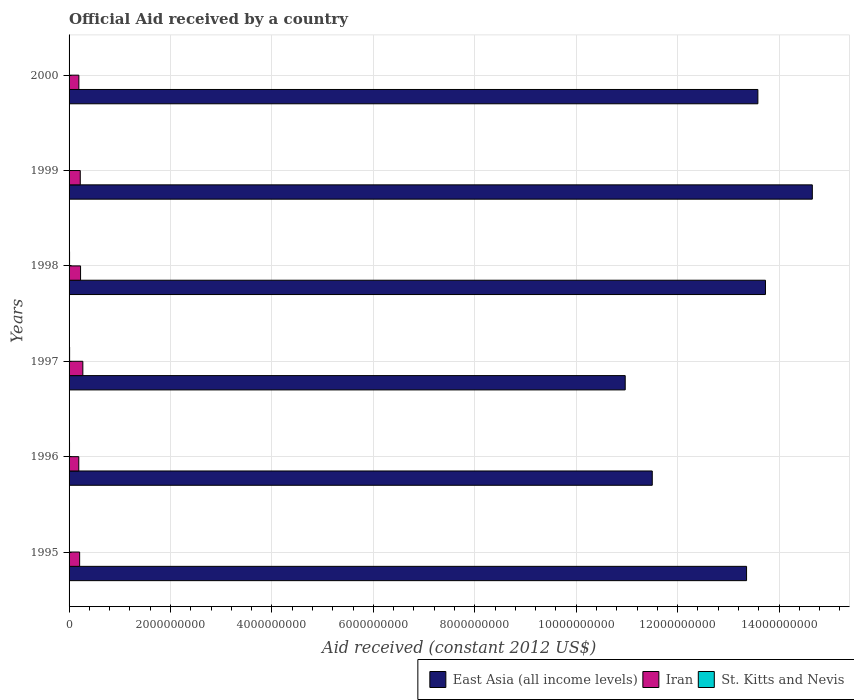Are the number of bars per tick equal to the number of legend labels?
Offer a very short reply. Yes. How many bars are there on the 2nd tick from the bottom?
Ensure brevity in your answer.  3. What is the net official aid received in Iran in 1999?
Offer a terse response. 2.21e+08. Across all years, what is the maximum net official aid received in East Asia (all income levels)?
Provide a succinct answer. 1.47e+1. Across all years, what is the minimum net official aid received in St. Kitts and Nevis?
Keep it short and to the point. 5.01e+06. In which year was the net official aid received in East Asia (all income levels) minimum?
Keep it short and to the point. 1997. What is the total net official aid received in Iran in the graph?
Your answer should be very brief. 1.31e+09. What is the difference between the net official aid received in East Asia (all income levels) in 1996 and that in 1998?
Offer a very short reply. -2.23e+09. What is the difference between the net official aid received in East Asia (all income levels) in 1996 and the net official aid received in Iran in 1995?
Your answer should be very brief. 1.13e+1. What is the average net official aid received in Iran per year?
Provide a short and direct response. 2.19e+08. In the year 1998, what is the difference between the net official aid received in East Asia (all income levels) and net official aid received in St. Kitts and Nevis?
Offer a very short reply. 1.37e+1. In how many years, is the net official aid received in East Asia (all income levels) greater than 4000000000 US$?
Offer a terse response. 6. What is the ratio of the net official aid received in East Asia (all income levels) in 1996 to that in 1999?
Ensure brevity in your answer.  0.78. What is the difference between the highest and the second highest net official aid received in St. Kitts and Nevis?
Make the answer very short. 7.40e+05. What is the difference between the highest and the lowest net official aid received in Iran?
Keep it short and to the point. 8.02e+07. In how many years, is the net official aid received in Iran greater than the average net official aid received in Iran taken over all years?
Your response must be concise. 3. Is the sum of the net official aid received in St. Kitts and Nevis in 1995 and 1997 greater than the maximum net official aid received in East Asia (all income levels) across all years?
Keep it short and to the point. No. What does the 2nd bar from the top in 2000 represents?
Offer a terse response. Iran. What does the 3rd bar from the bottom in 1998 represents?
Your answer should be compact. St. Kitts and Nevis. Is it the case that in every year, the sum of the net official aid received in St. Kitts and Nevis and net official aid received in Iran is greater than the net official aid received in East Asia (all income levels)?
Your answer should be very brief. No. How many bars are there?
Offer a terse response. 18. Are all the bars in the graph horizontal?
Make the answer very short. Yes. How many years are there in the graph?
Your answer should be very brief. 6. Are the values on the major ticks of X-axis written in scientific E-notation?
Give a very brief answer. No. Does the graph contain grids?
Provide a succinct answer. Yes. Where does the legend appear in the graph?
Make the answer very short. Bottom right. What is the title of the graph?
Your answer should be very brief. Official Aid received by a country. Does "Myanmar" appear as one of the legend labels in the graph?
Keep it short and to the point. No. What is the label or title of the X-axis?
Offer a terse response. Aid received (constant 2012 US$). What is the label or title of the Y-axis?
Provide a short and direct response. Years. What is the Aid received (constant 2012 US$) in East Asia (all income levels) in 1995?
Your answer should be very brief. 1.34e+1. What is the Aid received (constant 2012 US$) of Iran in 1995?
Your answer should be very brief. 2.08e+08. What is the Aid received (constant 2012 US$) in St. Kitts and Nevis in 1995?
Offer a very short reply. 5.01e+06. What is the Aid received (constant 2012 US$) of East Asia (all income levels) in 1996?
Ensure brevity in your answer.  1.15e+1. What is the Aid received (constant 2012 US$) in Iran in 1996?
Make the answer very short. 1.91e+08. What is the Aid received (constant 2012 US$) in St. Kitts and Nevis in 1996?
Your answer should be very brief. 9.19e+06. What is the Aid received (constant 2012 US$) of East Asia (all income levels) in 1997?
Your answer should be very brief. 1.10e+1. What is the Aid received (constant 2012 US$) in Iran in 1997?
Your answer should be compact. 2.72e+08. What is the Aid received (constant 2012 US$) of St. Kitts and Nevis in 1997?
Provide a succinct answer. 1.05e+07. What is the Aid received (constant 2012 US$) of East Asia (all income levels) in 1998?
Make the answer very short. 1.37e+1. What is the Aid received (constant 2012 US$) of Iran in 1998?
Ensure brevity in your answer.  2.27e+08. What is the Aid received (constant 2012 US$) of St. Kitts and Nevis in 1998?
Make the answer very short. 9.75e+06. What is the Aid received (constant 2012 US$) in East Asia (all income levels) in 1999?
Keep it short and to the point. 1.47e+1. What is the Aid received (constant 2012 US$) of Iran in 1999?
Your response must be concise. 2.21e+08. What is the Aid received (constant 2012 US$) in St. Kitts and Nevis in 1999?
Give a very brief answer. 6.83e+06. What is the Aid received (constant 2012 US$) of East Asia (all income levels) in 2000?
Provide a succinct answer. 1.36e+1. What is the Aid received (constant 2012 US$) of Iran in 2000?
Your answer should be compact. 1.93e+08. What is the Aid received (constant 2012 US$) of St. Kitts and Nevis in 2000?
Keep it short and to the point. 6.15e+06. Across all years, what is the maximum Aid received (constant 2012 US$) of East Asia (all income levels)?
Provide a short and direct response. 1.47e+1. Across all years, what is the maximum Aid received (constant 2012 US$) in Iran?
Your response must be concise. 2.72e+08. Across all years, what is the maximum Aid received (constant 2012 US$) of St. Kitts and Nevis?
Your answer should be compact. 1.05e+07. Across all years, what is the minimum Aid received (constant 2012 US$) in East Asia (all income levels)?
Your response must be concise. 1.10e+1. Across all years, what is the minimum Aid received (constant 2012 US$) in Iran?
Keep it short and to the point. 1.91e+08. Across all years, what is the minimum Aid received (constant 2012 US$) in St. Kitts and Nevis?
Give a very brief answer. 5.01e+06. What is the total Aid received (constant 2012 US$) in East Asia (all income levels) in the graph?
Your response must be concise. 7.78e+1. What is the total Aid received (constant 2012 US$) of Iran in the graph?
Ensure brevity in your answer.  1.31e+09. What is the total Aid received (constant 2012 US$) of St. Kitts and Nevis in the graph?
Provide a succinct answer. 4.74e+07. What is the difference between the Aid received (constant 2012 US$) in East Asia (all income levels) in 1995 and that in 1996?
Provide a succinct answer. 1.86e+09. What is the difference between the Aid received (constant 2012 US$) in Iran in 1995 and that in 1996?
Your answer should be compact. 1.70e+07. What is the difference between the Aid received (constant 2012 US$) in St. Kitts and Nevis in 1995 and that in 1996?
Your answer should be compact. -4.18e+06. What is the difference between the Aid received (constant 2012 US$) of East Asia (all income levels) in 1995 and that in 1997?
Offer a very short reply. 2.39e+09. What is the difference between the Aid received (constant 2012 US$) of Iran in 1995 and that in 1997?
Ensure brevity in your answer.  -6.32e+07. What is the difference between the Aid received (constant 2012 US$) in St. Kitts and Nevis in 1995 and that in 1997?
Keep it short and to the point. -5.48e+06. What is the difference between the Aid received (constant 2012 US$) of East Asia (all income levels) in 1995 and that in 1998?
Provide a short and direct response. -3.73e+08. What is the difference between the Aid received (constant 2012 US$) of Iran in 1995 and that in 1998?
Your answer should be compact. -1.81e+07. What is the difference between the Aid received (constant 2012 US$) of St. Kitts and Nevis in 1995 and that in 1998?
Your answer should be very brief. -4.74e+06. What is the difference between the Aid received (constant 2012 US$) in East Asia (all income levels) in 1995 and that in 1999?
Your answer should be compact. -1.30e+09. What is the difference between the Aid received (constant 2012 US$) of Iran in 1995 and that in 1999?
Make the answer very short. -1.24e+07. What is the difference between the Aid received (constant 2012 US$) in St. Kitts and Nevis in 1995 and that in 1999?
Offer a terse response. -1.82e+06. What is the difference between the Aid received (constant 2012 US$) of East Asia (all income levels) in 1995 and that in 2000?
Make the answer very short. -2.23e+08. What is the difference between the Aid received (constant 2012 US$) in Iran in 1995 and that in 2000?
Your answer should be very brief. 1.55e+07. What is the difference between the Aid received (constant 2012 US$) of St. Kitts and Nevis in 1995 and that in 2000?
Your answer should be compact. -1.14e+06. What is the difference between the Aid received (constant 2012 US$) in East Asia (all income levels) in 1996 and that in 1997?
Offer a terse response. 5.33e+08. What is the difference between the Aid received (constant 2012 US$) in Iran in 1996 and that in 1997?
Your answer should be compact. -8.02e+07. What is the difference between the Aid received (constant 2012 US$) in St. Kitts and Nevis in 1996 and that in 1997?
Offer a terse response. -1.30e+06. What is the difference between the Aid received (constant 2012 US$) of East Asia (all income levels) in 1996 and that in 1998?
Offer a terse response. -2.23e+09. What is the difference between the Aid received (constant 2012 US$) in Iran in 1996 and that in 1998?
Provide a short and direct response. -3.51e+07. What is the difference between the Aid received (constant 2012 US$) of St. Kitts and Nevis in 1996 and that in 1998?
Ensure brevity in your answer.  -5.60e+05. What is the difference between the Aid received (constant 2012 US$) of East Asia (all income levels) in 1996 and that in 1999?
Offer a very short reply. -3.16e+09. What is the difference between the Aid received (constant 2012 US$) in Iran in 1996 and that in 1999?
Offer a very short reply. -2.94e+07. What is the difference between the Aid received (constant 2012 US$) in St. Kitts and Nevis in 1996 and that in 1999?
Keep it short and to the point. 2.36e+06. What is the difference between the Aid received (constant 2012 US$) in East Asia (all income levels) in 1996 and that in 2000?
Ensure brevity in your answer.  -2.08e+09. What is the difference between the Aid received (constant 2012 US$) in Iran in 1996 and that in 2000?
Your answer should be very brief. -1.48e+06. What is the difference between the Aid received (constant 2012 US$) in St. Kitts and Nevis in 1996 and that in 2000?
Offer a very short reply. 3.04e+06. What is the difference between the Aid received (constant 2012 US$) of East Asia (all income levels) in 1997 and that in 1998?
Make the answer very short. -2.77e+09. What is the difference between the Aid received (constant 2012 US$) in Iran in 1997 and that in 1998?
Your answer should be very brief. 4.51e+07. What is the difference between the Aid received (constant 2012 US$) of St. Kitts and Nevis in 1997 and that in 1998?
Give a very brief answer. 7.40e+05. What is the difference between the Aid received (constant 2012 US$) of East Asia (all income levels) in 1997 and that in 1999?
Give a very brief answer. -3.69e+09. What is the difference between the Aid received (constant 2012 US$) in Iran in 1997 and that in 1999?
Your answer should be compact. 5.08e+07. What is the difference between the Aid received (constant 2012 US$) in St. Kitts and Nevis in 1997 and that in 1999?
Provide a short and direct response. 3.66e+06. What is the difference between the Aid received (constant 2012 US$) of East Asia (all income levels) in 1997 and that in 2000?
Ensure brevity in your answer.  -2.62e+09. What is the difference between the Aid received (constant 2012 US$) of Iran in 1997 and that in 2000?
Your answer should be compact. 7.87e+07. What is the difference between the Aid received (constant 2012 US$) in St. Kitts and Nevis in 1997 and that in 2000?
Your answer should be very brief. 4.34e+06. What is the difference between the Aid received (constant 2012 US$) in East Asia (all income levels) in 1998 and that in 1999?
Offer a terse response. -9.24e+08. What is the difference between the Aid received (constant 2012 US$) in Iran in 1998 and that in 1999?
Make the answer very short. 5.70e+06. What is the difference between the Aid received (constant 2012 US$) of St. Kitts and Nevis in 1998 and that in 1999?
Provide a short and direct response. 2.92e+06. What is the difference between the Aid received (constant 2012 US$) in East Asia (all income levels) in 1998 and that in 2000?
Offer a very short reply. 1.50e+08. What is the difference between the Aid received (constant 2012 US$) of Iran in 1998 and that in 2000?
Offer a very short reply. 3.36e+07. What is the difference between the Aid received (constant 2012 US$) in St. Kitts and Nevis in 1998 and that in 2000?
Offer a very short reply. 3.60e+06. What is the difference between the Aid received (constant 2012 US$) of East Asia (all income levels) in 1999 and that in 2000?
Your answer should be very brief. 1.07e+09. What is the difference between the Aid received (constant 2012 US$) of Iran in 1999 and that in 2000?
Offer a very short reply. 2.79e+07. What is the difference between the Aid received (constant 2012 US$) in St. Kitts and Nevis in 1999 and that in 2000?
Ensure brevity in your answer.  6.80e+05. What is the difference between the Aid received (constant 2012 US$) in East Asia (all income levels) in 1995 and the Aid received (constant 2012 US$) in Iran in 1996?
Ensure brevity in your answer.  1.32e+1. What is the difference between the Aid received (constant 2012 US$) in East Asia (all income levels) in 1995 and the Aid received (constant 2012 US$) in St. Kitts and Nevis in 1996?
Give a very brief answer. 1.34e+1. What is the difference between the Aid received (constant 2012 US$) of Iran in 1995 and the Aid received (constant 2012 US$) of St. Kitts and Nevis in 1996?
Offer a very short reply. 1.99e+08. What is the difference between the Aid received (constant 2012 US$) in East Asia (all income levels) in 1995 and the Aid received (constant 2012 US$) in Iran in 1997?
Ensure brevity in your answer.  1.31e+1. What is the difference between the Aid received (constant 2012 US$) in East Asia (all income levels) in 1995 and the Aid received (constant 2012 US$) in St. Kitts and Nevis in 1997?
Your answer should be compact. 1.33e+1. What is the difference between the Aid received (constant 2012 US$) of Iran in 1995 and the Aid received (constant 2012 US$) of St. Kitts and Nevis in 1997?
Give a very brief answer. 1.98e+08. What is the difference between the Aid received (constant 2012 US$) of East Asia (all income levels) in 1995 and the Aid received (constant 2012 US$) of Iran in 1998?
Give a very brief answer. 1.31e+1. What is the difference between the Aid received (constant 2012 US$) of East Asia (all income levels) in 1995 and the Aid received (constant 2012 US$) of St. Kitts and Nevis in 1998?
Your response must be concise. 1.34e+1. What is the difference between the Aid received (constant 2012 US$) of Iran in 1995 and the Aid received (constant 2012 US$) of St. Kitts and Nevis in 1998?
Provide a short and direct response. 1.99e+08. What is the difference between the Aid received (constant 2012 US$) of East Asia (all income levels) in 1995 and the Aid received (constant 2012 US$) of Iran in 1999?
Your response must be concise. 1.31e+1. What is the difference between the Aid received (constant 2012 US$) in East Asia (all income levels) in 1995 and the Aid received (constant 2012 US$) in St. Kitts and Nevis in 1999?
Make the answer very short. 1.34e+1. What is the difference between the Aid received (constant 2012 US$) in Iran in 1995 and the Aid received (constant 2012 US$) in St. Kitts and Nevis in 1999?
Your answer should be very brief. 2.02e+08. What is the difference between the Aid received (constant 2012 US$) of East Asia (all income levels) in 1995 and the Aid received (constant 2012 US$) of Iran in 2000?
Offer a terse response. 1.32e+1. What is the difference between the Aid received (constant 2012 US$) in East Asia (all income levels) in 1995 and the Aid received (constant 2012 US$) in St. Kitts and Nevis in 2000?
Ensure brevity in your answer.  1.34e+1. What is the difference between the Aid received (constant 2012 US$) of Iran in 1995 and the Aid received (constant 2012 US$) of St. Kitts and Nevis in 2000?
Ensure brevity in your answer.  2.02e+08. What is the difference between the Aid received (constant 2012 US$) in East Asia (all income levels) in 1996 and the Aid received (constant 2012 US$) in Iran in 1997?
Provide a short and direct response. 1.12e+1. What is the difference between the Aid received (constant 2012 US$) of East Asia (all income levels) in 1996 and the Aid received (constant 2012 US$) of St. Kitts and Nevis in 1997?
Offer a very short reply. 1.15e+1. What is the difference between the Aid received (constant 2012 US$) of Iran in 1996 and the Aid received (constant 2012 US$) of St. Kitts and Nevis in 1997?
Keep it short and to the point. 1.81e+08. What is the difference between the Aid received (constant 2012 US$) in East Asia (all income levels) in 1996 and the Aid received (constant 2012 US$) in Iran in 1998?
Keep it short and to the point. 1.13e+1. What is the difference between the Aid received (constant 2012 US$) of East Asia (all income levels) in 1996 and the Aid received (constant 2012 US$) of St. Kitts and Nevis in 1998?
Your response must be concise. 1.15e+1. What is the difference between the Aid received (constant 2012 US$) of Iran in 1996 and the Aid received (constant 2012 US$) of St. Kitts and Nevis in 1998?
Provide a short and direct response. 1.82e+08. What is the difference between the Aid received (constant 2012 US$) in East Asia (all income levels) in 1996 and the Aid received (constant 2012 US$) in Iran in 1999?
Give a very brief answer. 1.13e+1. What is the difference between the Aid received (constant 2012 US$) of East Asia (all income levels) in 1996 and the Aid received (constant 2012 US$) of St. Kitts and Nevis in 1999?
Make the answer very short. 1.15e+1. What is the difference between the Aid received (constant 2012 US$) in Iran in 1996 and the Aid received (constant 2012 US$) in St. Kitts and Nevis in 1999?
Give a very brief answer. 1.85e+08. What is the difference between the Aid received (constant 2012 US$) of East Asia (all income levels) in 1996 and the Aid received (constant 2012 US$) of Iran in 2000?
Provide a short and direct response. 1.13e+1. What is the difference between the Aid received (constant 2012 US$) of East Asia (all income levels) in 1996 and the Aid received (constant 2012 US$) of St. Kitts and Nevis in 2000?
Ensure brevity in your answer.  1.15e+1. What is the difference between the Aid received (constant 2012 US$) in Iran in 1996 and the Aid received (constant 2012 US$) in St. Kitts and Nevis in 2000?
Your answer should be very brief. 1.85e+08. What is the difference between the Aid received (constant 2012 US$) in East Asia (all income levels) in 1997 and the Aid received (constant 2012 US$) in Iran in 1998?
Make the answer very short. 1.07e+1. What is the difference between the Aid received (constant 2012 US$) in East Asia (all income levels) in 1997 and the Aid received (constant 2012 US$) in St. Kitts and Nevis in 1998?
Offer a very short reply. 1.10e+1. What is the difference between the Aid received (constant 2012 US$) of Iran in 1997 and the Aid received (constant 2012 US$) of St. Kitts and Nevis in 1998?
Provide a succinct answer. 2.62e+08. What is the difference between the Aid received (constant 2012 US$) in East Asia (all income levels) in 1997 and the Aid received (constant 2012 US$) in Iran in 1999?
Your answer should be compact. 1.07e+1. What is the difference between the Aid received (constant 2012 US$) of East Asia (all income levels) in 1997 and the Aid received (constant 2012 US$) of St. Kitts and Nevis in 1999?
Provide a succinct answer. 1.10e+1. What is the difference between the Aid received (constant 2012 US$) of Iran in 1997 and the Aid received (constant 2012 US$) of St. Kitts and Nevis in 1999?
Offer a very short reply. 2.65e+08. What is the difference between the Aid received (constant 2012 US$) of East Asia (all income levels) in 1997 and the Aid received (constant 2012 US$) of Iran in 2000?
Your answer should be very brief. 1.08e+1. What is the difference between the Aid received (constant 2012 US$) in East Asia (all income levels) in 1997 and the Aid received (constant 2012 US$) in St. Kitts and Nevis in 2000?
Make the answer very short. 1.10e+1. What is the difference between the Aid received (constant 2012 US$) of Iran in 1997 and the Aid received (constant 2012 US$) of St. Kitts and Nevis in 2000?
Your answer should be very brief. 2.65e+08. What is the difference between the Aid received (constant 2012 US$) in East Asia (all income levels) in 1998 and the Aid received (constant 2012 US$) in Iran in 1999?
Offer a very short reply. 1.35e+1. What is the difference between the Aid received (constant 2012 US$) in East Asia (all income levels) in 1998 and the Aid received (constant 2012 US$) in St. Kitts and Nevis in 1999?
Provide a succinct answer. 1.37e+1. What is the difference between the Aid received (constant 2012 US$) of Iran in 1998 and the Aid received (constant 2012 US$) of St. Kitts and Nevis in 1999?
Provide a succinct answer. 2.20e+08. What is the difference between the Aid received (constant 2012 US$) of East Asia (all income levels) in 1998 and the Aid received (constant 2012 US$) of Iran in 2000?
Offer a terse response. 1.35e+1. What is the difference between the Aid received (constant 2012 US$) in East Asia (all income levels) in 1998 and the Aid received (constant 2012 US$) in St. Kitts and Nevis in 2000?
Your response must be concise. 1.37e+1. What is the difference between the Aid received (constant 2012 US$) of Iran in 1998 and the Aid received (constant 2012 US$) of St. Kitts and Nevis in 2000?
Make the answer very short. 2.20e+08. What is the difference between the Aid received (constant 2012 US$) of East Asia (all income levels) in 1999 and the Aid received (constant 2012 US$) of Iran in 2000?
Your answer should be compact. 1.45e+1. What is the difference between the Aid received (constant 2012 US$) of East Asia (all income levels) in 1999 and the Aid received (constant 2012 US$) of St. Kitts and Nevis in 2000?
Your response must be concise. 1.47e+1. What is the difference between the Aid received (constant 2012 US$) in Iran in 1999 and the Aid received (constant 2012 US$) in St. Kitts and Nevis in 2000?
Provide a succinct answer. 2.15e+08. What is the average Aid received (constant 2012 US$) of East Asia (all income levels) per year?
Provide a succinct answer. 1.30e+1. What is the average Aid received (constant 2012 US$) of Iran per year?
Your answer should be very brief. 2.19e+08. What is the average Aid received (constant 2012 US$) in St. Kitts and Nevis per year?
Make the answer very short. 7.90e+06. In the year 1995, what is the difference between the Aid received (constant 2012 US$) of East Asia (all income levels) and Aid received (constant 2012 US$) of Iran?
Your answer should be compact. 1.32e+1. In the year 1995, what is the difference between the Aid received (constant 2012 US$) of East Asia (all income levels) and Aid received (constant 2012 US$) of St. Kitts and Nevis?
Provide a short and direct response. 1.34e+1. In the year 1995, what is the difference between the Aid received (constant 2012 US$) of Iran and Aid received (constant 2012 US$) of St. Kitts and Nevis?
Offer a terse response. 2.03e+08. In the year 1996, what is the difference between the Aid received (constant 2012 US$) of East Asia (all income levels) and Aid received (constant 2012 US$) of Iran?
Your response must be concise. 1.13e+1. In the year 1996, what is the difference between the Aid received (constant 2012 US$) of East Asia (all income levels) and Aid received (constant 2012 US$) of St. Kitts and Nevis?
Give a very brief answer. 1.15e+1. In the year 1996, what is the difference between the Aid received (constant 2012 US$) of Iran and Aid received (constant 2012 US$) of St. Kitts and Nevis?
Provide a succinct answer. 1.82e+08. In the year 1997, what is the difference between the Aid received (constant 2012 US$) in East Asia (all income levels) and Aid received (constant 2012 US$) in Iran?
Keep it short and to the point. 1.07e+1. In the year 1997, what is the difference between the Aid received (constant 2012 US$) in East Asia (all income levels) and Aid received (constant 2012 US$) in St. Kitts and Nevis?
Ensure brevity in your answer.  1.10e+1. In the year 1997, what is the difference between the Aid received (constant 2012 US$) of Iran and Aid received (constant 2012 US$) of St. Kitts and Nevis?
Offer a very short reply. 2.61e+08. In the year 1998, what is the difference between the Aid received (constant 2012 US$) of East Asia (all income levels) and Aid received (constant 2012 US$) of Iran?
Offer a terse response. 1.35e+1. In the year 1998, what is the difference between the Aid received (constant 2012 US$) in East Asia (all income levels) and Aid received (constant 2012 US$) in St. Kitts and Nevis?
Give a very brief answer. 1.37e+1. In the year 1998, what is the difference between the Aid received (constant 2012 US$) in Iran and Aid received (constant 2012 US$) in St. Kitts and Nevis?
Offer a terse response. 2.17e+08. In the year 1999, what is the difference between the Aid received (constant 2012 US$) in East Asia (all income levels) and Aid received (constant 2012 US$) in Iran?
Keep it short and to the point. 1.44e+1. In the year 1999, what is the difference between the Aid received (constant 2012 US$) of East Asia (all income levels) and Aid received (constant 2012 US$) of St. Kitts and Nevis?
Offer a very short reply. 1.46e+1. In the year 1999, what is the difference between the Aid received (constant 2012 US$) of Iran and Aid received (constant 2012 US$) of St. Kitts and Nevis?
Offer a very short reply. 2.14e+08. In the year 2000, what is the difference between the Aid received (constant 2012 US$) of East Asia (all income levels) and Aid received (constant 2012 US$) of Iran?
Make the answer very short. 1.34e+1. In the year 2000, what is the difference between the Aid received (constant 2012 US$) in East Asia (all income levels) and Aid received (constant 2012 US$) in St. Kitts and Nevis?
Ensure brevity in your answer.  1.36e+1. In the year 2000, what is the difference between the Aid received (constant 2012 US$) of Iran and Aid received (constant 2012 US$) of St. Kitts and Nevis?
Offer a terse response. 1.87e+08. What is the ratio of the Aid received (constant 2012 US$) in East Asia (all income levels) in 1995 to that in 1996?
Offer a terse response. 1.16. What is the ratio of the Aid received (constant 2012 US$) of Iran in 1995 to that in 1996?
Provide a succinct answer. 1.09. What is the ratio of the Aid received (constant 2012 US$) in St. Kitts and Nevis in 1995 to that in 1996?
Offer a terse response. 0.55. What is the ratio of the Aid received (constant 2012 US$) of East Asia (all income levels) in 1995 to that in 1997?
Give a very brief answer. 1.22. What is the ratio of the Aid received (constant 2012 US$) of Iran in 1995 to that in 1997?
Provide a succinct answer. 0.77. What is the ratio of the Aid received (constant 2012 US$) of St. Kitts and Nevis in 1995 to that in 1997?
Make the answer very short. 0.48. What is the ratio of the Aid received (constant 2012 US$) of East Asia (all income levels) in 1995 to that in 1998?
Make the answer very short. 0.97. What is the ratio of the Aid received (constant 2012 US$) of Iran in 1995 to that in 1998?
Keep it short and to the point. 0.92. What is the ratio of the Aid received (constant 2012 US$) of St. Kitts and Nevis in 1995 to that in 1998?
Provide a succinct answer. 0.51. What is the ratio of the Aid received (constant 2012 US$) in East Asia (all income levels) in 1995 to that in 1999?
Ensure brevity in your answer.  0.91. What is the ratio of the Aid received (constant 2012 US$) in Iran in 1995 to that in 1999?
Offer a terse response. 0.94. What is the ratio of the Aid received (constant 2012 US$) of St. Kitts and Nevis in 1995 to that in 1999?
Your answer should be very brief. 0.73. What is the ratio of the Aid received (constant 2012 US$) in East Asia (all income levels) in 1995 to that in 2000?
Your answer should be very brief. 0.98. What is the ratio of the Aid received (constant 2012 US$) in Iran in 1995 to that in 2000?
Make the answer very short. 1.08. What is the ratio of the Aid received (constant 2012 US$) of St. Kitts and Nevis in 1995 to that in 2000?
Your answer should be very brief. 0.81. What is the ratio of the Aid received (constant 2012 US$) of East Asia (all income levels) in 1996 to that in 1997?
Give a very brief answer. 1.05. What is the ratio of the Aid received (constant 2012 US$) in Iran in 1996 to that in 1997?
Your answer should be very brief. 0.7. What is the ratio of the Aid received (constant 2012 US$) of St. Kitts and Nevis in 1996 to that in 1997?
Your answer should be compact. 0.88. What is the ratio of the Aid received (constant 2012 US$) of East Asia (all income levels) in 1996 to that in 1998?
Ensure brevity in your answer.  0.84. What is the ratio of the Aid received (constant 2012 US$) in Iran in 1996 to that in 1998?
Provide a succinct answer. 0.85. What is the ratio of the Aid received (constant 2012 US$) in St. Kitts and Nevis in 1996 to that in 1998?
Ensure brevity in your answer.  0.94. What is the ratio of the Aid received (constant 2012 US$) of East Asia (all income levels) in 1996 to that in 1999?
Your answer should be very brief. 0.78. What is the ratio of the Aid received (constant 2012 US$) of Iran in 1996 to that in 1999?
Keep it short and to the point. 0.87. What is the ratio of the Aid received (constant 2012 US$) in St. Kitts and Nevis in 1996 to that in 1999?
Make the answer very short. 1.35. What is the ratio of the Aid received (constant 2012 US$) of East Asia (all income levels) in 1996 to that in 2000?
Your answer should be compact. 0.85. What is the ratio of the Aid received (constant 2012 US$) in St. Kitts and Nevis in 1996 to that in 2000?
Your response must be concise. 1.49. What is the ratio of the Aid received (constant 2012 US$) of East Asia (all income levels) in 1997 to that in 1998?
Provide a short and direct response. 0.8. What is the ratio of the Aid received (constant 2012 US$) in Iran in 1997 to that in 1998?
Give a very brief answer. 1.2. What is the ratio of the Aid received (constant 2012 US$) in St. Kitts and Nevis in 1997 to that in 1998?
Offer a terse response. 1.08. What is the ratio of the Aid received (constant 2012 US$) of East Asia (all income levels) in 1997 to that in 1999?
Ensure brevity in your answer.  0.75. What is the ratio of the Aid received (constant 2012 US$) in Iran in 1997 to that in 1999?
Your answer should be very brief. 1.23. What is the ratio of the Aid received (constant 2012 US$) of St. Kitts and Nevis in 1997 to that in 1999?
Your answer should be compact. 1.54. What is the ratio of the Aid received (constant 2012 US$) in East Asia (all income levels) in 1997 to that in 2000?
Your answer should be compact. 0.81. What is the ratio of the Aid received (constant 2012 US$) of Iran in 1997 to that in 2000?
Make the answer very short. 1.41. What is the ratio of the Aid received (constant 2012 US$) of St. Kitts and Nevis in 1997 to that in 2000?
Provide a short and direct response. 1.71. What is the ratio of the Aid received (constant 2012 US$) in East Asia (all income levels) in 1998 to that in 1999?
Keep it short and to the point. 0.94. What is the ratio of the Aid received (constant 2012 US$) in Iran in 1998 to that in 1999?
Provide a succinct answer. 1.03. What is the ratio of the Aid received (constant 2012 US$) in St. Kitts and Nevis in 1998 to that in 1999?
Provide a succinct answer. 1.43. What is the ratio of the Aid received (constant 2012 US$) of Iran in 1998 to that in 2000?
Your answer should be compact. 1.17. What is the ratio of the Aid received (constant 2012 US$) of St. Kitts and Nevis in 1998 to that in 2000?
Give a very brief answer. 1.59. What is the ratio of the Aid received (constant 2012 US$) in East Asia (all income levels) in 1999 to that in 2000?
Your answer should be very brief. 1.08. What is the ratio of the Aid received (constant 2012 US$) in Iran in 1999 to that in 2000?
Make the answer very short. 1.14. What is the ratio of the Aid received (constant 2012 US$) of St. Kitts and Nevis in 1999 to that in 2000?
Provide a succinct answer. 1.11. What is the difference between the highest and the second highest Aid received (constant 2012 US$) in East Asia (all income levels)?
Provide a short and direct response. 9.24e+08. What is the difference between the highest and the second highest Aid received (constant 2012 US$) in Iran?
Give a very brief answer. 4.51e+07. What is the difference between the highest and the second highest Aid received (constant 2012 US$) in St. Kitts and Nevis?
Make the answer very short. 7.40e+05. What is the difference between the highest and the lowest Aid received (constant 2012 US$) in East Asia (all income levels)?
Keep it short and to the point. 3.69e+09. What is the difference between the highest and the lowest Aid received (constant 2012 US$) of Iran?
Ensure brevity in your answer.  8.02e+07. What is the difference between the highest and the lowest Aid received (constant 2012 US$) in St. Kitts and Nevis?
Your response must be concise. 5.48e+06. 